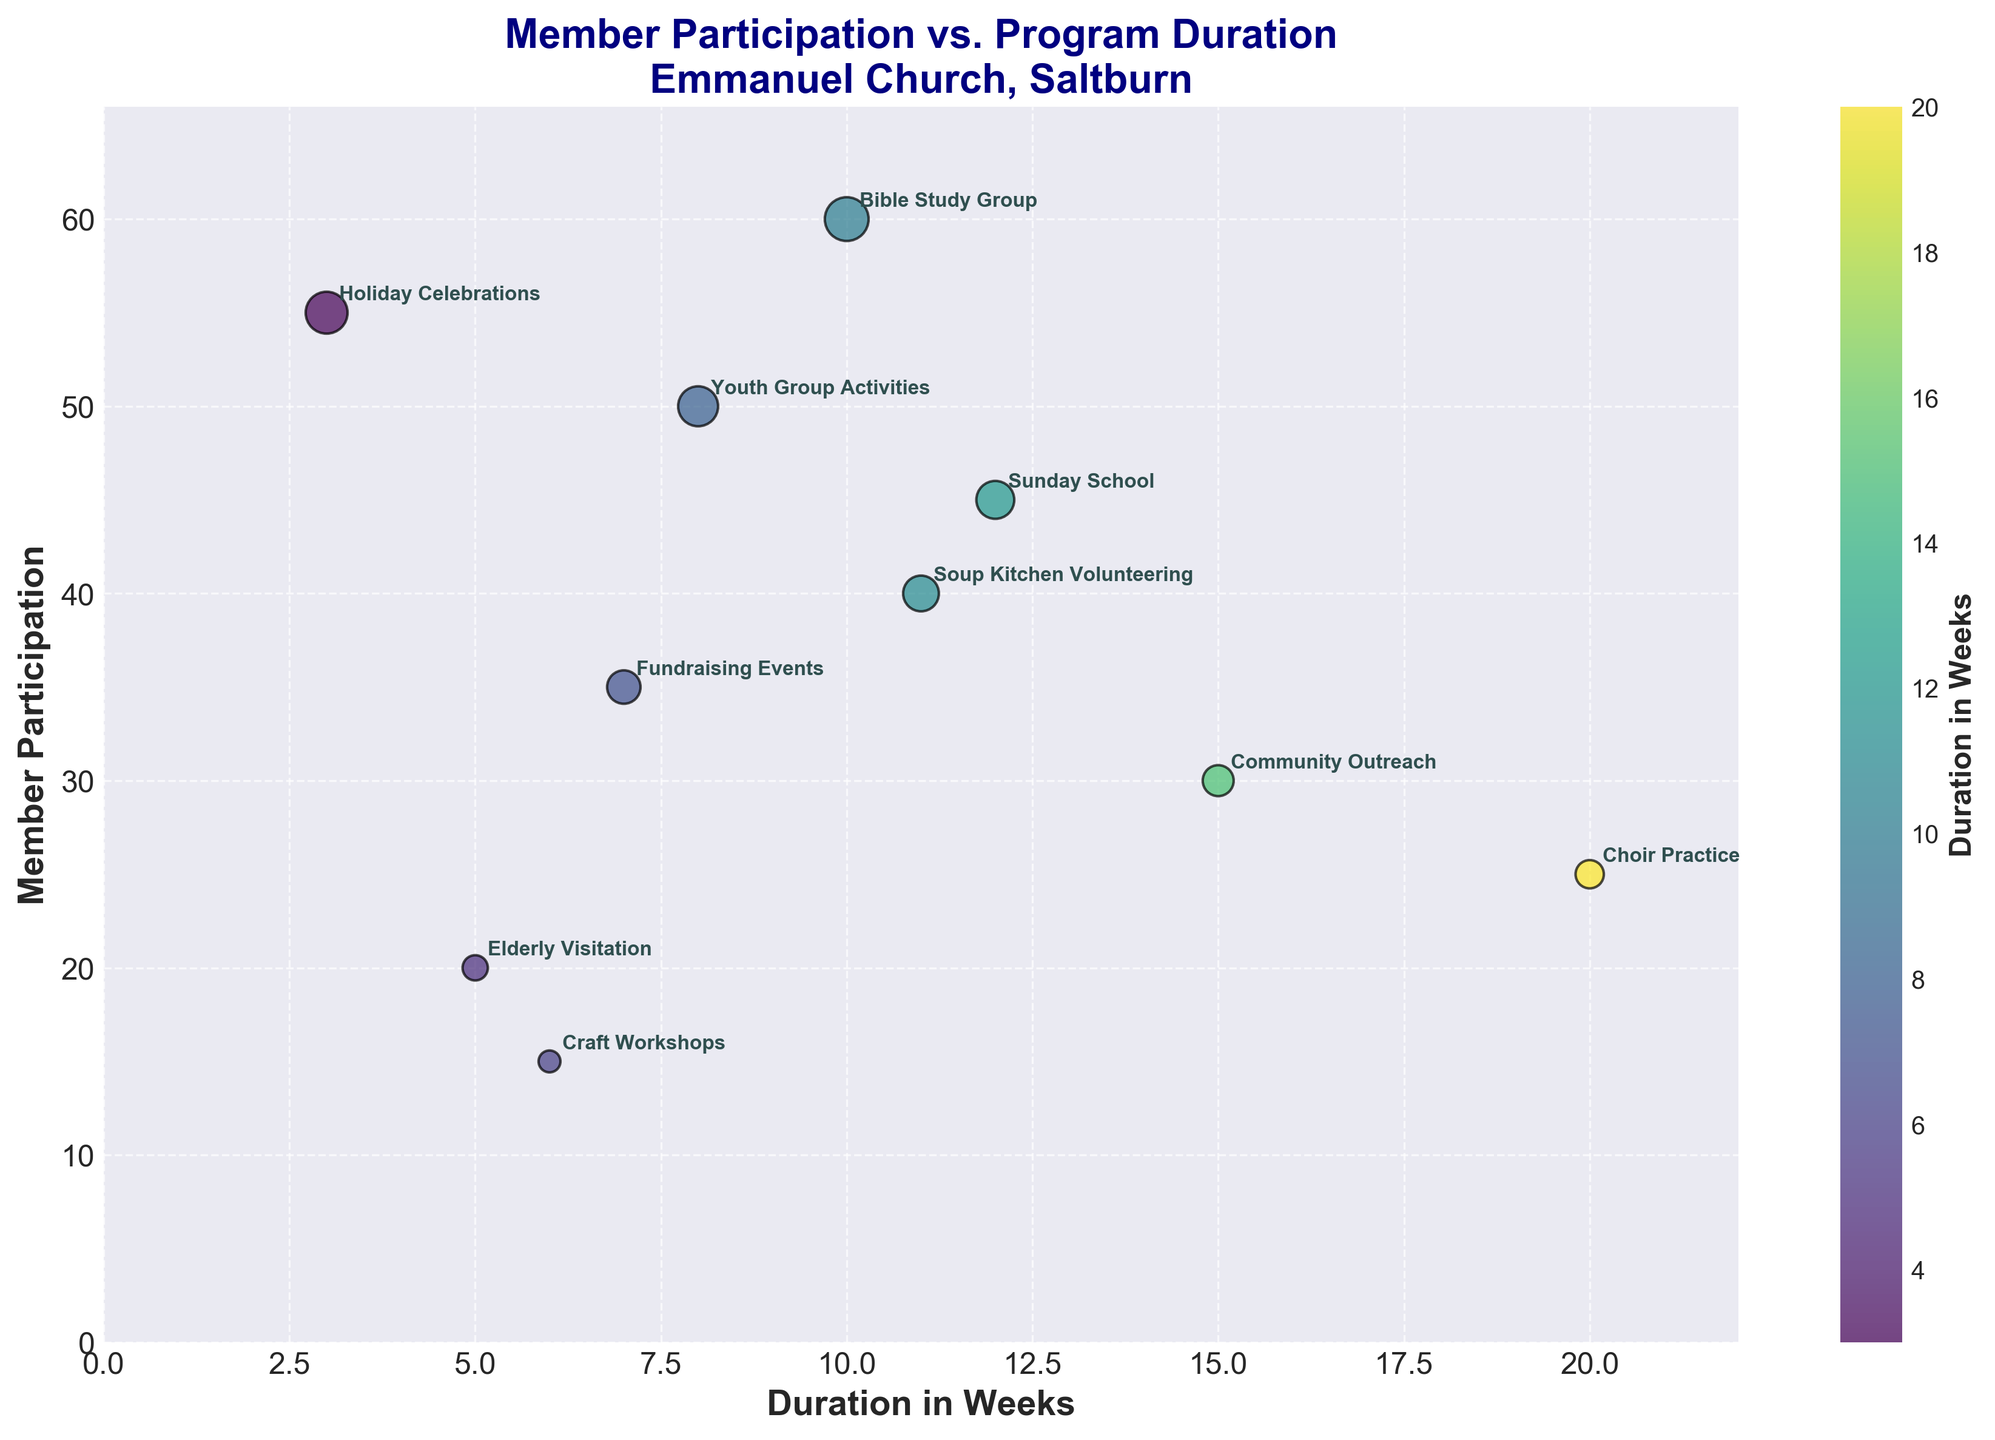What is the title of the scatter plot? The title is usually located at the top of the figure and helps describe what the figure is about. In this case, it states "Member Participation vs. Program Duration\nEmmanuel Church, Saltburn".
Answer: Member Participation vs. Program Duration Emmanuel Church, Saltburn What is the range of the x-axis? The x-axis represents "Duration in Weeks" and ranges from 0 to a little above the maximum value of the data, which is 20.
Answer: 0 to 22 Which program has the highest member participation? To find this, look for the data point with the highest y-value. In this case, "Bible Study Group" has the highest member participation at 60.
Answer: Bible Study Group How many programs have a duration of less than 10 weeks? Count the number of points on the scatter plot where the x-value (Duration in Weeks) is less than 10. These programs are "Youth Group Activities", "Elderly Visitation", "Fundraising Events", "Craft Workshops", and "Holiday Celebrations".
Answer: 5 Which program has the shortest duration, and how many members participate in it? The shortest duration corresponds to the smallest x-value. "Holiday Celebrations" has the shortest duration at 3 weeks with 55 members participating.
Answer: Holiday Celebrations, 55 members What is the average duration of the programs? To find the average, sum the durations and divide by the number of programs. The total duration is 12 + 20 + 15 + 10 + 8 + 5 + 7 + 6 + 3 + 11 = 97 weeks. There are 10 programs, so the average duration is 97/10.
Answer: 9.7 weeks Which two programs have the closest member participation? Look for the y-values that are closest to each other. "Community Outreach" and "Soup Kitchen Volunteering" have participations of 30 and 40 respectively, which are relatively close.
Answer: Community Outreach and Soup Kitchen Volunteering How many programs have member participation greater than 40? Count the number of points where the y-value (Member Participation) is greater than 40. Programs are "Sunday School", "Bible Study Group", "Youth Group Activities", "Holiday Celebrations", and "Soup Kitchen Volunteering".
Answer: 5 Identify the program with the largest size marker and explain why it is the largest. The largest marker corresponds to the data point with the highest y-value, because the size of the markers is proportional to the number of participants. "Bible Study Group" has the largest marker due to the highest participation of 60 members.
Answer: Bible Study Group Is there a general trend between program duration and member participation? To understand the trend, observe the scatter plot for any noticeable pattern. In this case, there's no clear trend indicating either an increase or decrease in participation with program duration.
Answer: No clear trend 